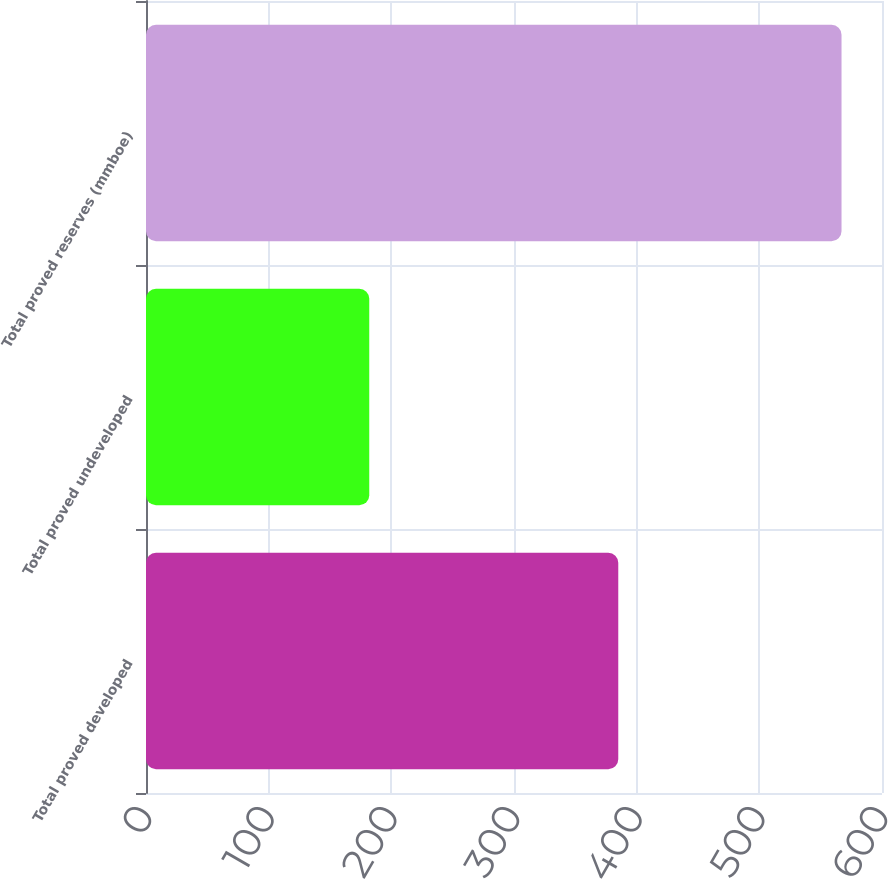Convert chart to OTSL. <chart><loc_0><loc_0><loc_500><loc_500><bar_chart><fcel>Total proved developed<fcel>Total proved undeveloped<fcel>Total proved reserves (mmboe)<nl><fcel>385<fcel>182<fcel>567<nl></chart> 